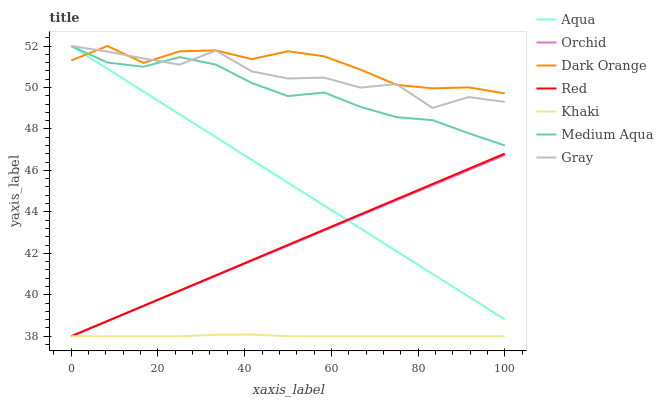Does Khaki have the minimum area under the curve?
Answer yes or no. Yes. Does Dark Orange have the maximum area under the curve?
Answer yes or no. Yes. Does Gray have the minimum area under the curve?
Answer yes or no. No. Does Gray have the maximum area under the curve?
Answer yes or no. No. Is Red the smoothest?
Answer yes or no. Yes. Is Gray the roughest?
Answer yes or no. Yes. Is Khaki the smoothest?
Answer yes or no. No. Is Khaki the roughest?
Answer yes or no. No. Does Khaki have the lowest value?
Answer yes or no. Yes. Does Gray have the lowest value?
Answer yes or no. No. Does Medium Aqua have the highest value?
Answer yes or no. Yes. Does Khaki have the highest value?
Answer yes or no. No. Is Orchid less than Medium Aqua?
Answer yes or no. Yes. Is Gray greater than Orchid?
Answer yes or no. Yes. Does Aqua intersect Medium Aqua?
Answer yes or no. Yes. Is Aqua less than Medium Aqua?
Answer yes or no. No. Is Aqua greater than Medium Aqua?
Answer yes or no. No. Does Orchid intersect Medium Aqua?
Answer yes or no. No. 